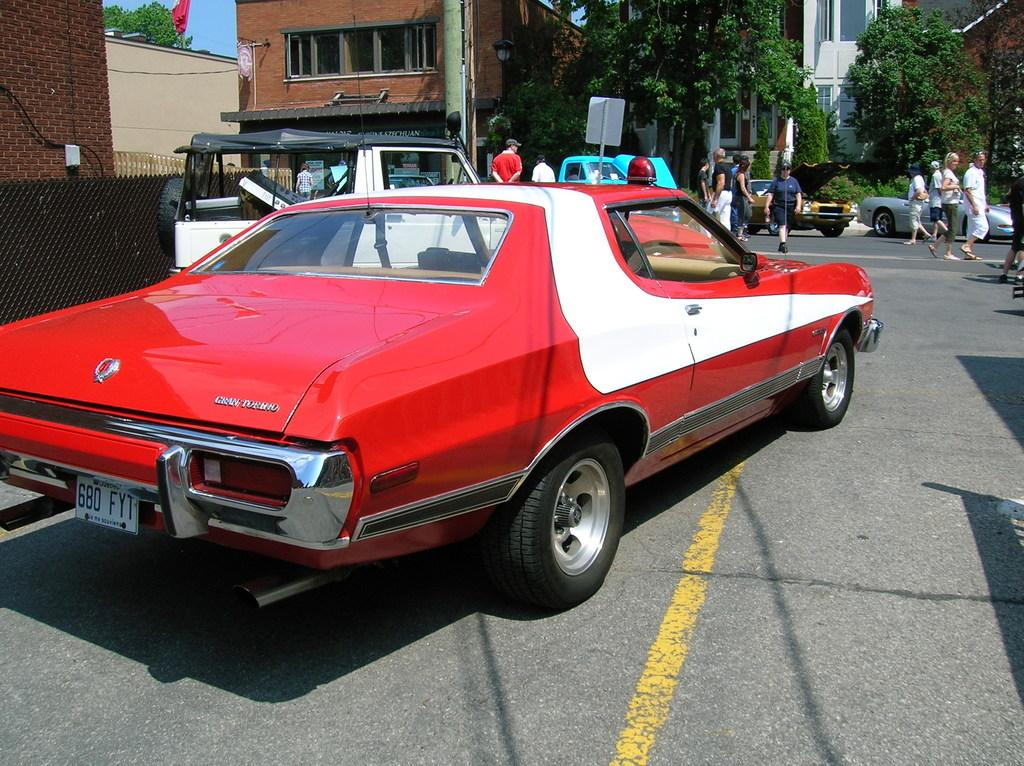What can be seen in the image? There are people, vehicles on the road, boards, a pole, trees, a mesh, buildings, and the sky visible in the background. Can you describe the vehicles in the image? The vehicles on the road are not specified, but they are present in the image. What type of structure is the pole supporting? The pole's purpose or the structure it supports is not mentioned in the facts. What is the color of the sky in the image? The color of the sky is not mentioned in the facts. What type of oven is being used to cook the pot in the image? There is no oven or pot present in the image. What operation is being performed by the people in the image? The specific actions or operations being performed by the people in the image are not mentioned in the facts. 